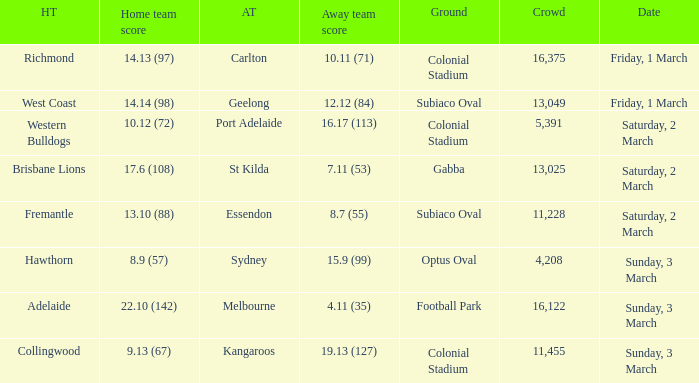What was the ground for away team essendon? Subiaco Oval. 